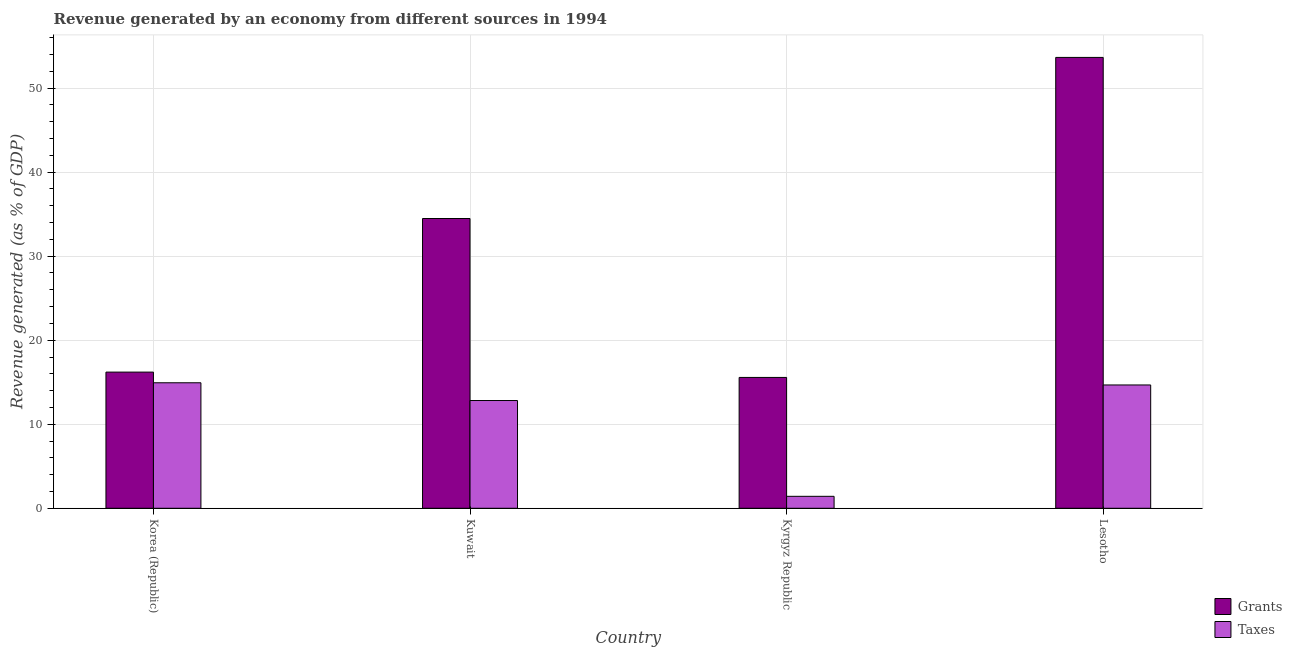Are the number of bars per tick equal to the number of legend labels?
Make the answer very short. Yes. How many bars are there on the 2nd tick from the right?
Your response must be concise. 2. What is the revenue generated by taxes in Korea (Republic)?
Offer a very short reply. 14.94. Across all countries, what is the maximum revenue generated by grants?
Your answer should be very brief. 53.66. Across all countries, what is the minimum revenue generated by grants?
Ensure brevity in your answer.  15.57. In which country was the revenue generated by grants maximum?
Keep it short and to the point. Lesotho. In which country was the revenue generated by taxes minimum?
Your response must be concise. Kyrgyz Republic. What is the total revenue generated by grants in the graph?
Offer a very short reply. 119.92. What is the difference between the revenue generated by grants in Korea (Republic) and that in Kuwait?
Give a very brief answer. -18.28. What is the difference between the revenue generated by grants in Kyrgyz Republic and the revenue generated by taxes in Kuwait?
Ensure brevity in your answer.  2.75. What is the average revenue generated by grants per country?
Offer a very short reply. 29.98. What is the difference between the revenue generated by taxes and revenue generated by grants in Kuwait?
Provide a short and direct response. -21.66. What is the ratio of the revenue generated by taxes in Korea (Republic) to that in Kyrgyz Republic?
Keep it short and to the point. 10.5. Is the difference between the revenue generated by grants in Korea (Republic) and Kyrgyz Republic greater than the difference between the revenue generated by taxes in Korea (Republic) and Kyrgyz Republic?
Make the answer very short. No. What is the difference between the highest and the second highest revenue generated by taxes?
Provide a succinct answer. 0.26. What is the difference between the highest and the lowest revenue generated by taxes?
Provide a succinct answer. 13.51. Is the sum of the revenue generated by taxes in Korea (Republic) and Kuwait greater than the maximum revenue generated by grants across all countries?
Keep it short and to the point. No. What does the 1st bar from the left in Korea (Republic) represents?
Make the answer very short. Grants. What does the 2nd bar from the right in Korea (Republic) represents?
Your answer should be compact. Grants. Are all the bars in the graph horizontal?
Your answer should be compact. No. How many countries are there in the graph?
Provide a short and direct response. 4. Where does the legend appear in the graph?
Ensure brevity in your answer.  Bottom right. What is the title of the graph?
Your response must be concise. Revenue generated by an economy from different sources in 1994. What is the label or title of the Y-axis?
Make the answer very short. Revenue generated (as % of GDP). What is the Revenue generated (as % of GDP) in Grants in Korea (Republic)?
Your answer should be very brief. 16.21. What is the Revenue generated (as % of GDP) of Taxes in Korea (Republic)?
Provide a succinct answer. 14.94. What is the Revenue generated (as % of GDP) in Grants in Kuwait?
Give a very brief answer. 34.49. What is the Revenue generated (as % of GDP) of Taxes in Kuwait?
Provide a short and direct response. 12.82. What is the Revenue generated (as % of GDP) in Grants in Kyrgyz Republic?
Provide a succinct answer. 15.57. What is the Revenue generated (as % of GDP) in Taxes in Kyrgyz Republic?
Give a very brief answer. 1.42. What is the Revenue generated (as % of GDP) in Grants in Lesotho?
Ensure brevity in your answer.  53.66. What is the Revenue generated (as % of GDP) of Taxes in Lesotho?
Provide a short and direct response. 14.68. Across all countries, what is the maximum Revenue generated (as % of GDP) of Grants?
Provide a succinct answer. 53.66. Across all countries, what is the maximum Revenue generated (as % of GDP) in Taxes?
Offer a very short reply. 14.94. Across all countries, what is the minimum Revenue generated (as % of GDP) of Grants?
Make the answer very short. 15.57. Across all countries, what is the minimum Revenue generated (as % of GDP) in Taxes?
Provide a short and direct response. 1.42. What is the total Revenue generated (as % of GDP) in Grants in the graph?
Offer a very short reply. 119.92. What is the total Revenue generated (as % of GDP) of Taxes in the graph?
Your response must be concise. 43.86. What is the difference between the Revenue generated (as % of GDP) in Grants in Korea (Republic) and that in Kuwait?
Ensure brevity in your answer.  -18.28. What is the difference between the Revenue generated (as % of GDP) in Taxes in Korea (Republic) and that in Kuwait?
Provide a succinct answer. 2.11. What is the difference between the Revenue generated (as % of GDP) of Grants in Korea (Republic) and that in Kyrgyz Republic?
Offer a very short reply. 0.63. What is the difference between the Revenue generated (as % of GDP) in Taxes in Korea (Republic) and that in Kyrgyz Republic?
Your answer should be very brief. 13.51. What is the difference between the Revenue generated (as % of GDP) in Grants in Korea (Republic) and that in Lesotho?
Keep it short and to the point. -37.45. What is the difference between the Revenue generated (as % of GDP) of Taxes in Korea (Republic) and that in Lesotho?
Your answer should be compact. 0.26. What is the difference between the Revenue generated (as % of GDP) in Grants in Kuwait and that in Kyrgyz Republic?
Your answer should be compact. 18.91. What is the difference between the Revenue generated (as % of GDP) of Taxes in Kuwait and that in Kyrgyz Republic?
Provide a short and direct response. 11.4. What is the difference between the Revenue generated (as % of GDP) in Grants in Kuwait and that in Lesotho?
Your answer should be very brief. -19.17. What is the difference between the Revenue generated (as % of GDP) in Taxes in Kuwait and that in Lesotho?
Keep it short and to the point. -1.85. What is the difference between the Revenue generated (as % of GDP) in Grants in Kyrgyz Republic and that in Lesotho?
Ensure brevity in your answer.  -38.08. What is the difference between the Revenue generated (as % of GDP) in Taxes in Kyrgyz Republic and that in Lesotho?
Your response must be concise. -13.25. What is the difference between the Revenue generated (as % of GDP) of Grants in Korea (Republic) and the Revenue generated (as % of GDP) of Taxes in Kuwait?
Provide a short and direct response. 3.38. What is the difference between the Revenue generated (as % of GDP) in Grants in Korea (Republic) and the Revenue generated (as % of GDP) in Taxes in Kyrgyz Republic?
Keep it short and to the point. 14.78. What is the difference between the Revenue generated (as % of GDP) in Grants in Korea (Republic) and the Revenue generated (as % of GDP) in Taxes in Lesotho?
Ensure brevity in your answer.  1.53. What is the difference between the Revenue generated (as % of GDP) of Grants in Kuwait and the Revenue generated (as % of GDP) of Taxes in Kyrgyz Republic?
Ensure brevity in your answer.  33.06. What is the difference between the Revenue generated (as % of GDP) of Grants in Kuwait and the Revenue generated (as % of GDP) of Taxes in Lesotho?
Offer a terse response. 19.81. What is the difference between the Revenue generated (as % of GDP) of Grants in Kyrgyz Republic and the Revenue generated (as % of GDP) of Taxes in Lesotho?
Your response must be concise. 0.9. What is the average Revenue generated (as % of GDP) in Grants per country?
Ensure brevity in your answer.  29.98. What is the average Revenue generated (as % of GDP) of Taxes per country?
Ensure brevity in your answer.  10.96. What is the difference between the Revenue generated (as % of GDP) in Grants and Revenue generated (as % of GDP) in Taxes in Korea (Republic)?
Offer a very short reply. 1.27. What is the difference between the Revenue generated (as % of GDP) in Grants and Revenue generated (as % of GDP) in Taxes in Kuwait?
Your answer should be compact. 21.66. What is the difference between the Revenue generated (as % of GDP) in Grants and Revenue generated (as % of GDP) in Taxes in Kyrgyz Republic?
Your response must be concise. 14.15. What is the difference between the Revenue generated (as % of GDP) in Grants and Revenue generated (as % of GDP) in Taxes in Lesotho?
Offer a very short reply. 38.98. What is the ratio of the Revenue generated (as % of GDP) of Grants in Korea (Republic) to that in Kuwait?
Ensure brevity in your answer.  0.47. What is the ratio of the Revenue generated (as % of GDP) in Taxes in Korea (Republic) to that in Kuwait?
Provide a short and direct response. 1.16. What is the ratio of the Revenue generated (as % of GDP) of Grants in Korea (Republic) to that in Kyrgyz Republic?
Keep it short and to the point. 1.04. What is the ratio of the Revenue generated (as % of GDP) of Taxes in Korea (Republic) to that in Kyrgyz Republic?
Your answer should be compact. 10.5. What is the ratio of the Revenue generated (as % of GDP) of Grants in Korea (Republic) to that in Lesotho?
Your answer should be compact. 0.3. What is the ratio of the Revenue generated (as % of GDP) of Taxes in Korea (Republic) to that in Lesotho?
Offer a very short reply. 1.02. What is the ratio of the Revenue generated (as % of GDP) of Grants in Kuwait to that in Kyrgyz Republic?
Give a very brief answer. 2.21. What is the ratio of the Revenue generated (as % of GDP) of Taxes in Kuwait to that in Kyrgyz Republic?
Offer a very short reply. 9.01. What is the ratio of the Revenue generated (as % of GDP) of Grants in Kuwait to that in Lesotho?
Offer a terse response. 0.64. What is the ratio of the Revenue generated (as % of GDP) in Taxes in Kuwait to that in Lesotho?
Provide a succinct answer. 0.87. What is the ratio of the Revenue generated (as % of GDP) of Grants in Kyrgyz Republic to that in Lesotho?
Provide a short and direct response. 0.29. What is the ratio of the Revenue generated (as % of GDP) in Taxes in Kyrgyz Republic to that in Lesotho?
Provide a short and direct response. 0.1. What is the difference between the highest and the second highest Revenue generated (as % of GDP) of Grants?
Make the answer very short. 19.17. What is the difference between the highest and the second highest Revenue generated (as % of GDP) of Taxes?
Offer a very short reply. 0.26. What is the difference between the highest and the lowest Revenue generated (as % of GDP) of Grants?
Make the answer very short. 38.08. What is the difference between the highest and the lowest Revenue generated (as % of GDP) in Taxes?
Keep it short and to the point. 13.51. 